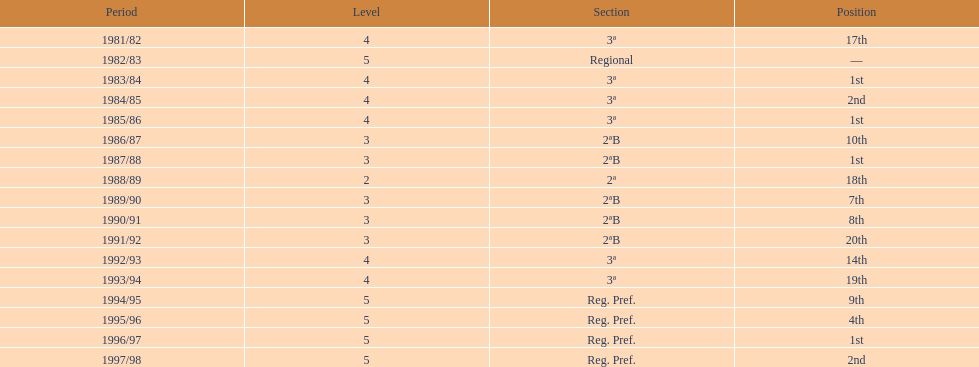Which season(s) earned first place? 1983/84, 1985/86, 1987/88, 1996/97. 